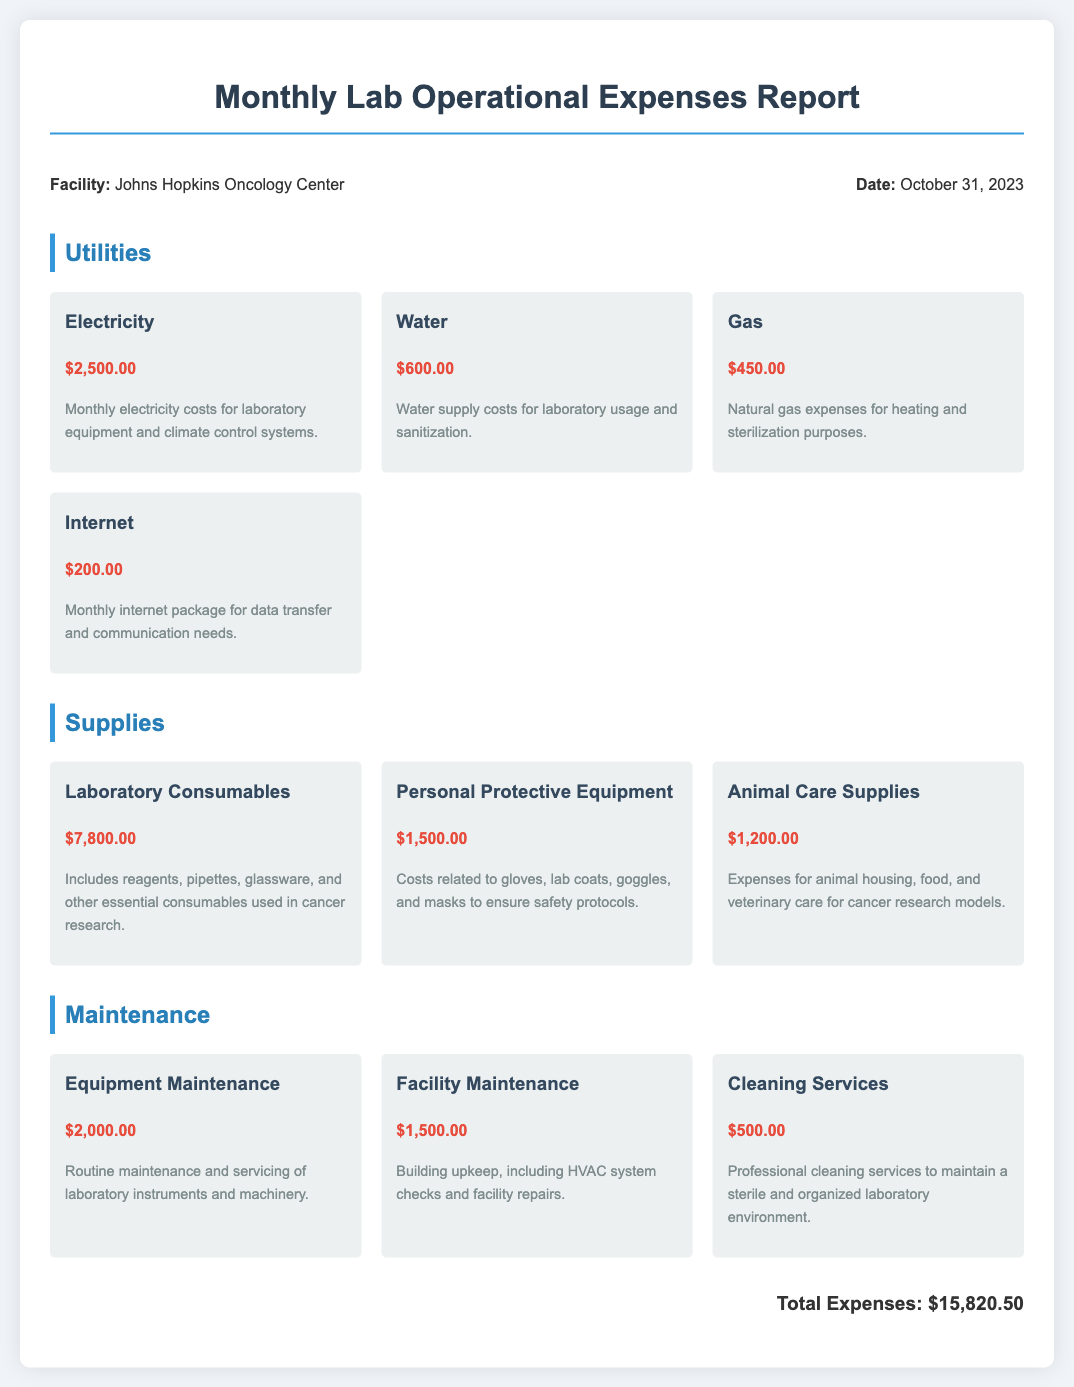What is the total amount spent on utilities? The total spent on utilities is derived from the individual utility costs listed in the document. Adding the costs $2,500.00 (Electricity) + $600.00 (Water) + $450.00 (Gas) + $200.00 (Internet) results in a total of $3,750.00.
Answer: $3,750.00 What is the date of the report? The report states the date prominently near the top. The date mentioned is October 31, 2023.
Answer: October 31, 2023 How much was spent on laboratory consumables? The amount for laboratory consumables is explicitly written in the supplies section as $7,800.00.
Answer: $7,800.00 What is the cost of cleaning services? The cost of cleaning services is listed under the maintenance section of the document, which is $500.00.
Answer: $500.00 Which facility is this report for? The facility name is presented within the report information section, indicating it's for the Johns Hopkins Oncology Center.
Answer: Johns Hopkins Oncology Center What is the total amount of all expenses? The total expenses are clearly indicated at the bottom of the document as $15,820.50 after calculating all individual costs.
Answer: $15,820.50 What is the cost of personal protective equipment? The document outlines personal protective equipment costs as $1,500.00 within the supplies section.
Answer: $1,500.00 Which utility has the highest expense? Comparing the listed utility expenses, electricity has the highest cost at $2,500.00.
Answer: Electricity What maintenance cost is allocated for equipment maintenance? The section for maintenance details that equipment maintenance costs $2,000.00.
Answer: $2,000.00 